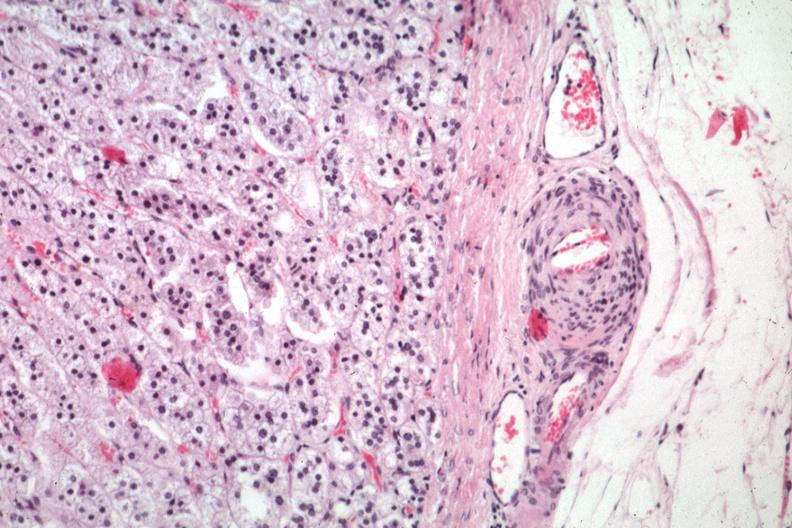does this image show typical lesion in small artery just outside capsule?
Answer the question using a single word or phrase. Yes 